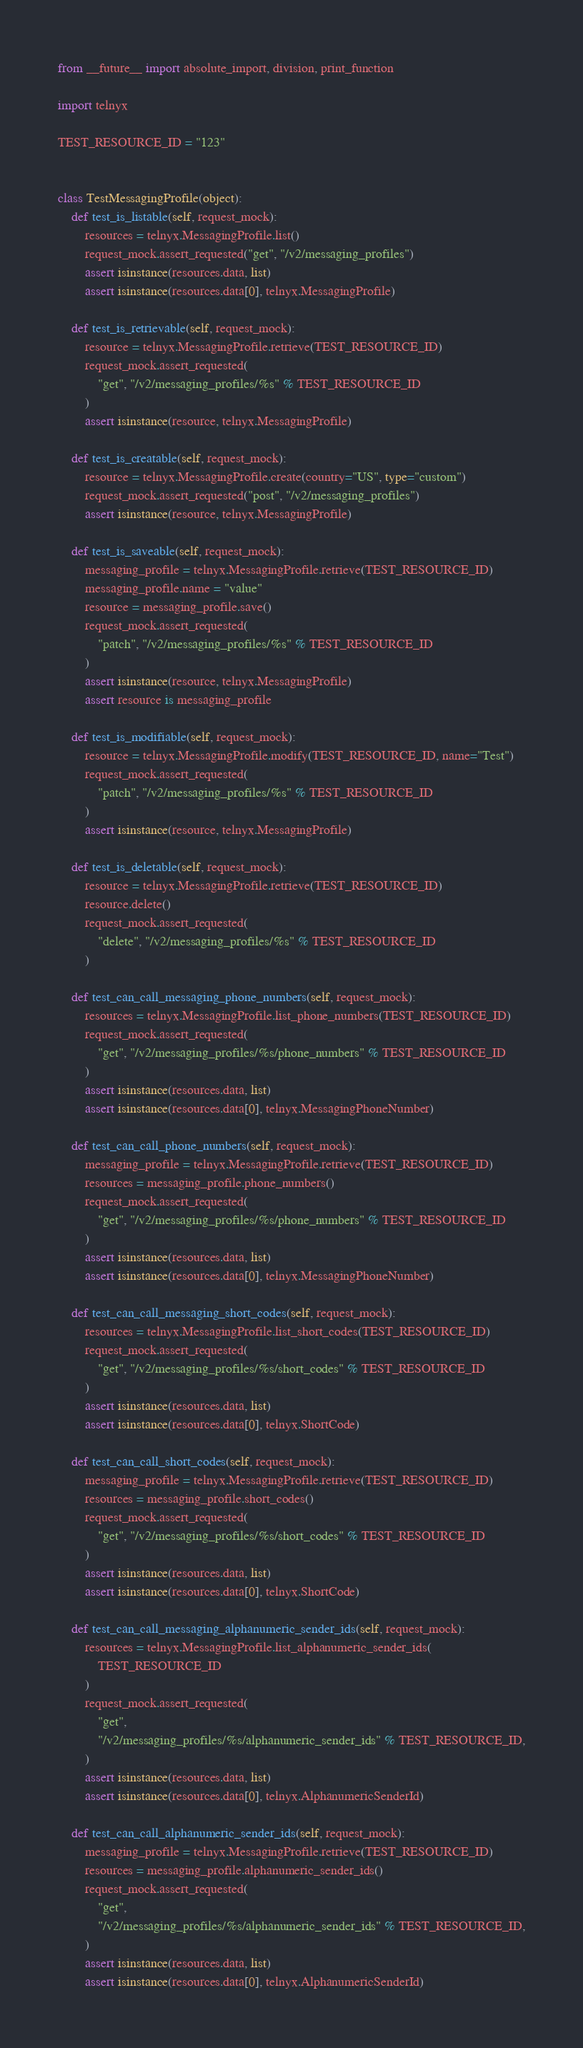<code> <loc_0><loc_0><loc_500><loc_500><_Python_>from __future__ import absolute_import, division, print_function

import telnyx

TEST_RESOURCE_ID = "123"


class TestMessagingProfile(object):
    def test_is_listable(self, request_mock):
        resources = telnyx.MessagingProfile.list()
        request_mock.assert_requested("get", "/v2/messaging_profiles")
        assert isinstance(resources.data, list)
        assert isinstance(resources.data[0], telnyx.MessagingProfile)

    def test_is_retrievable(self, request_mock):
        resource = telnyx.MessagingProfile.retrieve(TEST_RESOURCE_ID)
        request_mock.assert_requested(
            "get", "/v2/messaging_profiles/%s" % TEST_RESOURCE_ID
        )
        assert isinstance(resource, telnyx.MessagingProfile)

    def test_is_creatable(self, request_mock):
        resource = telnyx.MessagingProfile.create(country="US", type="custom")
        request_mock.assert_requested("post", "/v2/messaging_profiles")
        assert isinstance(resource, telnyx.MessagingProfile)

    def test_is_saveable(self, request_mock):
        messaging_profile = telnyx.MessagingProfile.retrieve(TEST_RESOURCE_ID)
        messaging_profile.name = "value"
        resource = messaging_profile.save()
        request_mock.assert_requested(
            "patch", "/v2/messaging_profiles/%s" % TEST_RESOURCE_ID
        )
        assert isinstance(resource, telnyx.MessagingProfile)
        assert resource is messaging_profile

    def test_is_modifiable(self, request_mock):
        resource = telnyx.MessagingProfile.modify(TEST_RESOURCE_ID, name="Test")
        request_mock.assert_requested(
            "patch", "/v2/messaging_profiles/%s" % TEST_RESOURCE_ID
        )
        assert isinstance(resource, telnyx.MessagingProfile)

    def test_is_deletable(self, request_mock):
        resource = telnyx.MessagingProfile.retrieve(TEST_RESOURCE_ID)
        resource.delete()
        request_mock.assert_requested(
            "delete", "/v2/messaging_profiles/%s" % TEST_RESOURCE_ID
        )

    def test_can_call_messaging_phone_numbers(self, request_mock):
        resources = telnyx.MessagingProfile.list_phone_numbers(TEST_RESOURCE_ID)
        request_mock.assert_requested(
            "get", "/v2/messaging_profiles/%s/phone_numbers" % TEST_RESOURCE_ID
        )
        assert isinstance(resources.data, list)
        assert isinstance(resources.data[0], telnyx.MessagingPhoneNumber)

    def test_can_call_phone_numbers(self, request_mock):
        messaging_profile = telnyx.MessagingProfile.retrieve(TEST_RESOURCE_ID)
        resources = messaging_profile.phone_numbers()
        request_mock.assert_requested(
            "get", "/v2/messaging_profiles/%s/phone_numbers" % TEST_RESOURCE_ID
        )
        assert isinstance(resources.data, list)
        assert isinstance(resources.data[0], telnyx.MessagingPhoneNumber)

    def test_can_call_messaging_short_codes(self, request_mock):
        resources = telnyx.MessagingProfile.list_short_codes(TEST_RESOURCE_ID)
        request_mock.assert_requested(
            "get", "/v2/messaging_profiles/%s/short_codes" % TEST_RESOURCE_ID
        )
        assert isinstance(resources.data, list)
        assert isinstance(resources.data[0], telnyx.ShortCode)

    def test_can_call_short_codes(self, request_mock):
        messaging_profile = telnyx.MessagingProfile.retrieve(TEST_RESOURCE_ID)
        resources = messaging_profile.short_codes()
        request_mock.assert_requested(
            "get", "/v2/messaging_profiles/%s/short_codes" % TEST_RESOURCE_ID
        )
        assert isinstance(resources.data, list)
        assert isinstance(resources.data[0], telnyx.ShortCode)

    def test_can_call_messaging_alphanumeric_sender_ids(self, request_mock):
        resources = telnyx.MessagingProfile.list_alphanumeric_sender_ids(
            TEST_RESOURCE_ID
        )
        request_mock.assert_requested(
            "get",
            "/v2/messaging_profiles/%s/alphanumeric_sender_ids" % TEST_RESOURCE_ID,
        )
        assert isinstance(resources.data, list)
        assert isinstance(resources.data[0], telnyx.AlphanumericSenderId)

    def test_can_call_alphanumeric_sender_ids(self, request_mock):
        messaging_profile = telnyx.MessagingProfile.retrieve(TEST_RESOURCE_ID)
        resources = messaging_profile.alphanumeric_sender_ids()
        request_mock.assert_requested(
            "get",
            "/v2/messaging_profiles/%s/alphanumeric_sender_ids" % TEST_RESOURCE_ID,
        )
        assert isinstance(resources.data, list)
        assert isinstance(resources.data[0], telnyx.AlphanumericSenderId)
</code> 